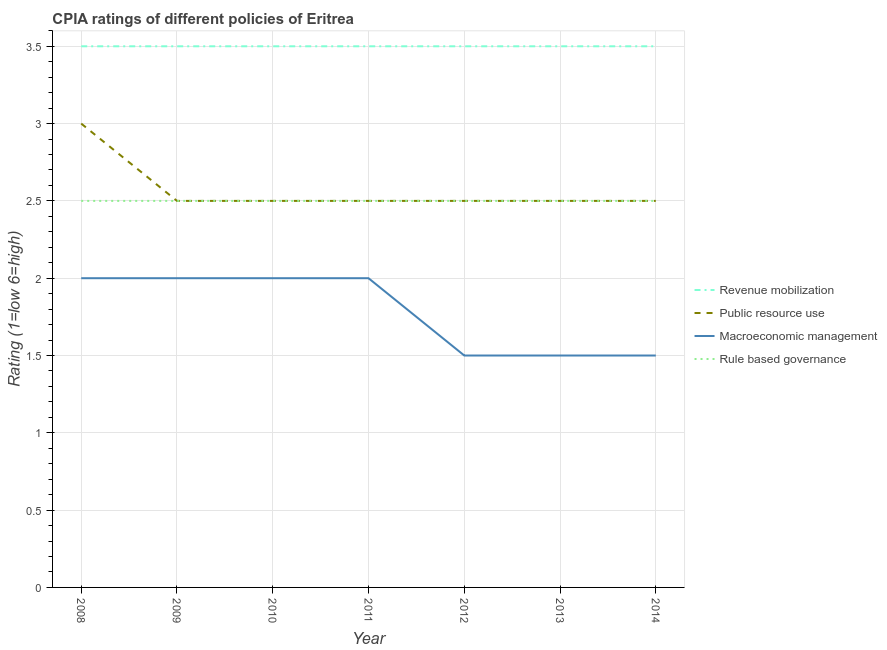How many different coloured lines are there?
Ensure brevity in your answer.  4. Does the line corresponding to cpia rating of revenue mobilization intersect with the line corresponding to cpia rating of macroeconomic management?
Offer a very short reply. No. Is the number of lines equal to the number of legend labels?
Make the answer very short. Yes. Across all years, what is the maximum cpia rating of revenue mobilization?
Offer a terse response. 3.5. In which year was the cpia rating of rule based governance maximum?
Provide a short and direct response. 2008. What is the difference between the cpia rating of rule based governance in 2008 and that in 2014?
Provide a succinct answer. 0. What is the average cpia rating of revenue mobilization per year?
Offer a very short reply. 3.5. What is the ratio of the cpia rating of rule based governance in 2009 to that in 2014?
Provide a succinct answer. 1. Is the difference between the cpia rating of rule based governance in 2009 and 2010 greater than the difference between the cpia rating of macroeconomic management in 2009 and 2010?
Ensure brevity in your answer.  No. What is the difference between the highest and the lowest cpia rating of revenue mobilization?
Provide a short and direct response. 0. In how many years, is the cpia rating of public resource use greater than the average cpia rating of public resource use taken over all years?
Make the answer very short. 1. Is the cpia rating of revenue mobilization strictly less than the cpia rating of macroeconomic management over the years?
Offer a terse response. No. What is the difference between two consecutive major ticks on the Y-axis?
Your response must be concise. 0.5. Does the graph contain grids?
Ensure brevity in your answer.  Yes. Where does the legend appear in the graph?
Offer a very short reply. Center right. How many legend labels are there?
Your answer should be compact. 4. How are the legend labels stacked?
Give a very brief answer. Vertical. What is the title of the graph?
Your answer should be compact. CPIA ratings of different policies of Eritrea. Does "Belgium" appear as one of the legend labels in the graph?
Ensure brevity in your answer.  No. What is the label or title of the Y-axis?
Offer a very short reply. Rating (1=low 6=high). What is the Rating (1=low 6=high) of Rule based governance in 2008?
Your response must be concise. 2.5. What is the Rating (1=low 6=high) of Public resource use in 2009?
Give a very brief answer. 2.5. What is the Rating (1=low 6=high) in Macroeconomic management in 2009?
Offer a very short reply. 2. What is the Rating (1=low 6=high) in Public resource use in 2010?
Ensure brevity in your answer.  2.5. What is the Rating (1=low 6=high) of Macroeconomic management in 2011?
Your response must be concise. 2. What is the Rating (1=low 6=high) of Rule based governance in 2012?
Keep it short and to the point. 2.5. What is the Rating (1=low 6=high) in Rule based governance in 2013?
Ensure brevity in your answer.  2.5. What is the Rating (1=low 6=high) in Revenue mobilization in 2014?
Offer a terse response. 3.5. What is the Rating (1=low 6=high) in Public resource use in 2014?
Offer a terse response. 2.5. What is the Rating (1=low 6=high) of Rule based governance in 2014?
Your response must be concise. 2.5. Across all years, what is the maximum Rating (1=low 6=high) of Revenue mobilization?
Provide a succinct answer. 3.5. Across all years, what is the minimum Rating (1=low 6=high) of Macroeconomic management?
Your answer should be compact. 1.5. What is the total Rating (1=low 6=high) in Revenue mobilization in the graph?
Ensure brevity in your answer.  24.5. What is the total Rating (1=low 6=high) of Public resource use in the graph?
Your response must be concise. 18. What is the total Rating (1=low 6=high) of Rule based governance in the graph?
Your answer should be compact. 17.5. What is the difference between the Rating (1=low 6=high) of Public resource use in 2008 and that in 2009?
Provide a succinct answer. 0.5. What is the difference between the Rating (1=low 6=high) of Rule based governance in 2008 and that in 2009?
Offer a very short reply. 0. What is the difference between the Rating (1=low 6=high) of Public resource use in 2008 and that in 2010?
Your answer should be compact. 0.5. What is the difference between the Rating (1=low 6=high) of Rule based governance in 2008 and that in 2011?
Offer a terse response. 0. What is the difference between the Rating (1=low 6=high) of Revenue mobilization in 2008 and that in 2012?
Your response must be concise. 0. What is the difference between the Rating (1=low 6=high) of Revenue mobilization in 2008 and that in 2013?
Give a very brief answer. 0. What is the difference between the Rating (1=low 6=high) of Public resource use in 2008 and that in 2013?
Offer a terse response. 0.5. What is the difference between the Rating (1=low 6=high) in Macroeconomic management in 2008 and that in 2013?
Your answer should be very brief. 0.5. What is the difference between the Rating (1=low 6=high) in Public resource use in 2008 and that in 2014?
Your answer should be very brief. 0.5. What is the difference between the Rating (1=low 6=high) in Rule based governance in 2008 and that in 2014?
Offer a very short reply. 0. What is the difference between the Rating (1=low 6=high) in Macroeconomic management in 2009 and that in 2010?
Ensure brevity in your answer.  0. What is the difference between the Rating (1=low 6=high) of Macroeconomic management in 2009 and that in 2011?
Provide a succinct answer. 0. What is the difference between the Rating (1=low 6=high) of Public resource use in 2009 and that in 2012?
Offer a very short reply. 0. What is the difference between the Rating (1=low 6=high) of Macroeconomic management in 2009 and that in 2012?
Keep it short and to the point. 0.5. What is the difference between the Rating (1=low 6=high) in Rule based governance in 2009 and that in 2012?
Your answer should be very brief. 0. What is the difference between the Rating (1=low 6=high) in Revenue mobilization in 2009 and that in 2014?
Make the answer very short. 0. What is the difference between the Rating (1=low 6=high) in Public resource use in 2009 and that in 2014?
Give a very brief answer. 0. What is the difference between the Rating (1=low 6=high) of Macroeconomic management in 2009 and that in 2014?
Offer a terse response. 0.5. What is the difference between the Rating (1=low 6=high) of Public resource use in 2010 and that in 2011?
Ensure brevity in your answer.  0. What is the difference between the Rating (1=low 6=high) of Revenue mobilization in 2010 and that in 2013?
Give a very brief answer. 0. What is the difference between the Rating (1=low 6=high) in Public resource use in 2010 and that in 2013?
Ensure brevity in your answer.  0. What is the difference between the Rating (1=low 6=high) of Macroeconomic management in 2010 and that in 2013?
Ensure brevity in your answer.  0.5. What is the difference between the Rating (1=low 6=high) of Rule based governance in 2010 and that in 2013?
Provide a short and direct response. 0. What is the difference between the Rating (1=low 6=high) of Revenue mobilization in 2010 and that in 2014?
Your answer should be very brief. 0. What is the difference between the Rating (1=low 6=high) of Public resource use in 2010 and that in 2014?
Your answer should be very brief. 0. What is the difference between the Rating (1=low 6=high) in Macroeconomic management in 2010 and that in 2014?
Keep it short and to the point. 0.5. What is the difference between the Rating (1=low 6=high) of Rule based governance in 2010 and that in 2014?
Ensure brevity in your answer.  0. What is the difference between the Rating (1=low 6=high) in Public resource use in 2011 and that in 2012?
Give a very brief answer. 0. What is the difference between the Rating (1=low 6=high) of Rule based governance in 2011 and that in 2012?
Offer a very short reply. 0. What is the difference between the Rating (1=low 6=high) in Revenue mobilization in 2011 and that in 2013?
Provide a succinct answer. 0. What is the difference between the Rating (1=low 6=high) in Macroeconomic management in 2011 and that in 2013?
Keep it short and to the point. 0.5. What is the difference between the Rating (1=low 6=high) in Macroeconomic management in 2011 and that in 2014?
Offer a very short reply. 0.5. What is the difference between the Rating (1=low 6=high) of Revenue mobilization in 2012 and that in 2013?
Make the answer very short. 0. What is the difference between the Rating (1=low 6=high) of Macroeconomic management in 2012 and that in 2013?
Ensure brevity in your answer.  0. What is the difference between the Rating (1=low 6=high) of Rule based governance in 2012 and that in 2013?
Offer a terse response. 0. What is the difference between the Rating (1=low 6=high) of Public resource use in 2012 and that in 2014?
Provide a succinct answer. 0. What is the difference between the Rating (1=low 6=high) in Public resource use in 2013 and that in 2014?
Your answer should be compact. 0. What is the difference between the Rating (1=low 6=high) in Revenue mobilization in 2008 and the Rating (1=low 6=high) in Public resource use in 2009?
Provide a succinct answer. 1. What is the difference between the Rating (1=low 6=high) of Public resource use in 2008 and the Rating (1=low 6=high) of Macroeconomic management in 2009?
Your answer should be very brief. 1. What is the difference between the Rating (1=low 6=high) in Revenue mobilization in 2008 and the Rating (1=low 6=high) in Macroeconomic management in 2010?
Your response must be concise. 1.5. What is the difference between the Rating (1=low 6=high) of Revenue mobilization in 2008 and the Rating (1=low 6=high) of Rule based governance in 2010?
Offer a very short reply. 1. What is the difference between the Rating (1=low 6=high) of Public resource use in 2008 and the Rating (1=low 6=high) of Macroeconomic management in 2010?
Provide a succinct answer. 1. What is the difference between the Rating (1=low 6=high) of Revenue mobilization in 2008 and the Rating (1=low 6=high) of Public resource use in 2011?
Give a very brief answer. 1. What is the difference between the Rating (1=low 6=high) in Revenue mobilization in 2008 and the Rating (1=low 6=high) in Macroeconomic management in 2011?
Offer a very short reply. 1.5. What is the difference between the Rating (1=low 6=high) in Macroeconomic management in 2008 and the Rating (1=low 6=high) in Rule based governance in 2011?
Keep it short and to the point. -0.5. What is the difference between the Rating (1=low 6=high) of Public resource use in 2008 and the Rating (1=low 6=high) of Rule based governance in 2012?
Your response must be concise. 0.5. What is the difference between the Rating (1=low 6=high) in Revenue mobilization in 2008 and the Rating (1=low 6=high) in Public resource use in 2013?
Keep it short and to the point. 1. What is the difference between the Rating (1=low 6=high) of Revenue mobilization in 2008 and the Rating (1=low 6=high) of Macroeconomic management in 2013?
Keep it short and to the point. 2. What is the difference between the Rating (1=low 6=high) in Public resource use in 2008 and the Rating (1=low 6=high) in Macroeconomic management in 2013?
Give a very brief answer. 1.5. What is the difference between the Rating (1=low 6=high) in Revenue mobilization in 2008 and the Rating (1=low 6=high) in Public resource use in 2014?
Keep it short and to the point. 1. What is the difference between the Rating (1=low 6=high) in Revenue mobilization in 2008 and the Rating (1=low 6=high) in Macroeconomic management in 2014?
Keep it short and to the point. 2. What is the difference between the Rating (1=low 6=high) in Revenue mobilization in 2008 and the Rating (1=low 6=high) in Rule based governance in 2014?
Ensure brevity in your answer.  1. What is the difference between the Rating (1=low 6=high) of Revenue mobilization in 2009 and the Rating (1=low 6=high) of Public resource use in 2010?
Offer a terse response. 1. What is the difference between the Rating (1=low 6=high) in Revenue mobilization in 2009 and the Rating (1=low 6=high) in Macroeconomic management in 2010?
Provide a short and direct response. 1.5. What is the difference between the Rating (1=low 6=high) in Public resource use in 2009 and the Rating (1=low 6=high) in Rule based governance in 2010?
Offer a very short reply. 0. What is the difference between the Rating (1=low 6=high) of Revenue mobilization in 2009 and the Rating (1=low 6=high) of Macroeconomic management in 2011?
Ensure brevity in your answer.  1.5. What is the difference between the Rating (1=low 6=high) of Revenue mobilization in 2009 and the Rating (1=low 6=high) of Rule based governance in 2011?
Give a very brief answer. 1. What is the difference between the Rating (1=low 6=high) in Macroeconomic management in 2009 and the Rating (1=low 6=high) in Rule based governance in 2011?
Offer a very short reply. -0.5. What is the difference between the Rating (1=low 6=high) in Revenue mobilization in 2009 and the Rating (1=low 6=high) in Macroeconomic management in 2012?
Ensure brevity in your answer.  2. What is the difference between the Rating (1=low 6=high) of Public resource use in 2009 and the Rating (1=low 6=high) of Macroeconomic management in 2012?
Offer a very short reply. 1. What is the difference between the Rating (1=low 6=high) in Macroeconomic management in 2009 and the Rating (1=low 6=high) in Rule based governance in 2012?
Make the answer very short. -0.5. What is the difference between the Rating (1=low 6=high) in Revenue mobilization in 2009 and the Rating (1=low 6=high) in Public resource use in 2013?
Keep it short and to the point. 1. What is the difference between the Rating (1=low 6=high) of Revenue mobilization in 2009 and the Rating (1=low 6=high) of Rule based governance in 2013?
Give a very brief answer. 1. What is the difference between the Rating (1=low 6=high) in Public resource use in 2009 and the Rating (1=low 6=high) in Macroeconomic management in 2013?
Offer a terse response. 1. What is the difference between the Rating (1=low 6=high) of Revenue mobilization in 2009 and the Rating (1=low 6=high) of Macroeconomic management in 2014?
Your answer should be very brief. 2. What is the difference between the Rating (1=low 6=high) of Macroeconomic management in 2009 and the Rating (1=low 6=high) of Rule based governance in 2014?
Your answer should be compact. -0.5. What is the difference between the Rating (1=low 6=high) in Revenue mobilization in 2010 and the Rating (1=low 6=high) in Rule based governance in 2011?
Your response must be concise. 1. What is the difference between the Rating (1=low 6=high) of Macroeconomic management in 2010 and the Rating (1=low 6=high) of Rule based governance in 2011?
Give a very brief answer. -0.5. What is the difference between the Rating (1=low 6=high) of Revenue mobilization in 2010 and the Rating (1=low 6=high) of Macroeconomic management in 2013?
Provide a succinct answer. 2. What is the difference between the Rating (1=low 6=high) in Public resource use in 2010 and the Rating (1=low 6=high) in Macroeconomic management in 2013?
Offer a very short reply. 1. What is the difference between the Rating (1=low 6=high) in Macroeconomic management in 2010 and the Rating (1=low 6=high) in Rule based governance in 2013?
Provide a succinct answer. -0.5. What is the difference between the Rating (1=low 6=high) in Revenue mobilization in 2010 and the Rating (1=low 6=high) in Public resource use in 2014?
Your answer should be compact. 1. What is the difference between the Rating (1=low 6=high) in Public resource use in 2010 and the Rating (1=low 6=high) in Macroeconomic management in 2014?
Give a very brief answer. 1. What is the difference between the Rating (1=low 6=high) of Macroeconomic management in 2011 and the Rating (1=low 6=high) of Rule based governance in 2012?
Keep it short and to the point. -0.5. What is the difference between the Rating (1=low 6=high) in Revenue mobilization in 2011 and the Rating (1=low 6=high) in Macroeconomic management in 2013?
Offer a terse response. 2. What is the difference between the Rating (1=low 6=high) in Public resource use in 2011 and the Rating (1=low 6=high) in Rule based governance in 2013?
Offer a very short reply. 0. What is the difference between the Rating (1=low 6=high) in Revenue mobilization in 2011 and the Rating (1=low 6=high) in Public resource use in 2014?
Your response must be concise. 1. What is the difference between the Rating (1=low 6=high) of Revenue mobilization in 2011 and the Rating (1=low 6=high) of Rule based governance in 2014?
Your answer should be very brief. 1. What is the difference between the Rating (1=low 6=high) in Public resource use in 2011 and the Rating (1=low 6=high) in Macroeconomic management in 2014?
Offer a very short reply. 1. What is the difference between the Rating (1=low 6=high) of Public resource use in 2011 and the Rating (1=low 6=high) of Rule based governance in 2014?
Provide a succinct answer. 0. What is the difference between the Rating (1=low 6=high) of Revenue mobilization in 2012 and the Rating (1=low 6=high) of Public resource use in 2013?
Your answer should be compact. 1. What is the difference between the Rating (1=low 6=high) of Revenue mobilization in 2012 and the Rating (1=low 6=high) of Macroeconomic management in 2013?
Your answer should be compact. 2. What is the difference between the Rating (1=low 6=high) in Revenue mobilization in 2012 and the Rating (1=low 6=high) in Rule based governance in 2013?
Make the answer very short. 1. What is the difference between the Rating (1=low 6=high) of Macroeconomic management in 2012 and the Rating (1=low 6=high) of Rule based governance in 2013?
Your response must be concise. -1. What is the difference between the Rating (1=low 6=high) in Revenue mobilization in 2012 and the Rating (1=low 6=high) in Macroeconomic management in 2014?
Your response must be concise. 2. What is the difference between the Rating (1=low 6=high) of Revenue mobilization in 2012 and the Rating (1=low 6=high) of Rule based governance in 2014?
Make the answer very short. 1. What is the difference between the Rating (1=low 6=high) of Public resource use in 2012 and the Rating (1=low 6=high) of Macroeconomic management in 2014?
Give a very brief answer. 1. What is the difference between the Rating (1=low 6=high) of Revenue mobilization in 2013 and the Rating (1=low 6=high) of Macroeconomic management in 2014?
Provide a succinct answer. 2. What is the difference between the Rating (1=low 6=high) of Public resource use in 2013 and the Rating (1=low 6=high) of Macroeconomic management in 2014?
Provide a short and direct response. 1. What is the difference between the Rating (1=low 6=high) of Public resource use in 2013 and the Rating (1=low 6=high) of Rule based governance in 2014?
Ensure brevity in your answer.  0. What is the difference between the Rating (1=low 6=high) in Macroeconomic management in 2013 and the Rating (1=low 6=high) in Rule based governance in 2014?
Make the answer very short. -1. What is the average Rating (1=low 6=high) of Revenue mobilization per year?
Offer a very short reply. 3.5. What is the average Rating (1=low 6=high) of Public resource use per year?
Your answer should be compact. 2.57. What is the average Rating (1=low 6=high) of Macroeconomic management per year?
Your answer should be compact. 1.79. In the year 2008, what is the difference between the Rating (1=low 6=high) of Revenue mobilization and Rating (1=low 6=high) of Rule based governance?
Your response must be concise. 1. In the year 2008, what is the difference between the Rating (1=low 6=high) of Macroeconomic management and Rating (1=low 6=high) of Rule based governance?
Ensure brevity in your answer.  -0.5. In the year 2009, what is the difference between the Rating (1=low 6=high) in Revenue mobilization and Rating (1=low 6=high) in Public resource use?
Your response must be concise. 1. In the year 2009, what is the difference between the Rating (1=low 6=high) in Revenue mobilization and Rating (1=low 6=high) in Rule based governance?
Provide a succinct answer. 1. In the year 2009, what is the difference between the Rating (1=low 6=high) in Public resource use and Rating (1=low 6=high) in Macroeconomic management?
Offer a very short reply. 0.5. In the year 2009, what is the difference between the Rating (1=low 6=high) in Public resource use and Rating (1=low 6=high) in Rule based governance?
Your answer should be compact. 0. In the year 2010, what is the difference between the Rating (1=low 6=high) of Revenue mobilization and Rating (1=low 6=high) of Public resource use?
Offer a terse response. 1. In the year 2010, what is the difference between the Rating (1=low 6=high) in Revenue mobilization and Rating (1=low 6=high) in Macroeconomic management?
Offer a terse response. 1.5. In the year 2010, what is the difference between the Rating (1=low 6=high) of Revenue mobilization and Rating (1=low 6=high) of Rule based governance?
Give a very brief answer. 1. In the year 2010, what is the difference between the Rating (1=low 6=high) of Public resource use and Rating (1=low 6=high) of Rule based governance?
Offer a very short reply. 0. In the year 2010, what is the difference between the Rating (1=low 6=high) of Macroeconomic management and Rating (1=low 6=high) of Rule based governance?
Offer a very short reply. -0.5. In the year 2011, what is the difference between the Rating (1=low 6=high) of Revenue mobilization and Rating (1=low 6=high) of Macroeconomic management?
Make the answer very short. 1.5. In the year 2011, what is the difference between the Rating (1=low 6=high) in Revenue mobilization and Rating (1=low 6=high) in Rule based governance?
Your answer should be compact. 1. In the year 2011, what is the difference between the Rating (1=low 6=high) of Macroeconomic management and Rating (1=low 6=high) of Rule based governance?
Make the answer very short. -0.5. In the year 2012, what is the difference between the Rating (1=low 6=high) in Revenue mobilization and Rating (1=low 6=high) in Macroeconomic management?
Provide a short and direct response. 2. In the year 2012, what is the difference between the Rating (1=low 6=high) in Revenue mobilization and Rating (1=low 6=high) in Rule based governance?
Ensure brevity in your answer.  1. In the year 2012, what is the difference between the Rating (1=low 6=high) of Public resource use and Rating (1=low 6=high) of Macroeconomic management?
Ensure brevity in your answer.  1. In the year 2012, what is the difference between the Rating (1=low 6=high) in Macroeconomic management and Rating (1=low 6=high) in Rule based governance?
Your answer should be very brief. -1. In the year 2013, what is the difference between the Rating (1=low 6=high) of Revenue mobilization and Rating (1=low 6=high) of Macroeconomic management?
Give a very brief answer. 2. In the year 2013, what is the difference between the Rating (1=low 6=high) in Public resource use and Rating (1=low 6=high) in Rule based governance?
Your answer should be compact. 0. In the year 2013, what is the difference between the Rating (1=low 6=high) of Macroeconomic management and Rating (1=low 6=high) of Rule based governance?
Make the answer very short. -1. In the year 2014, what is the difference between the Rating (1=low 6=high) in Revenue mobilization and Rating (1=low 6=high) in Rule based governance?
Offer a terse response. 1. In the year 2014, what is the difference between the Rating (1=low 6=high) in Macroeconomic management and Rating (1=low 6=high) in Rule based governance?
Your response must be concise. -1. What is the ratio of the Rating (1=low 6=high) of Revenue mobilization in 2008 to that in 2009?
Provide a succinct answer. 1. What is the ratio of the Rating (1=low 6=high) of Macroeconomic management in 2008 to that in 2009?
Provide a succinct answer. 1. What is the ratio of the Rating (1=low 6=high) of Rule based governance in 2008 to that in 2010?
Offer a terse response. 1. What is the ratio of the Rating (1=low 6=high) in Public resource use in 2008 to that in 2011?
Give a very brief answer. 1.2. What is the ratio of the Rating (1=low 6=high) of Macroeconomic management in 2008 to that in 2011?
Your answer should be very brief. 1. What is the ratio of the Rating (1=low 6=high) of Rule based governance in 2008 to that in 2011?
Your response must be concise. 1. What is the ratio of the Rating (1=low 6=high) of Revenue mobilization in 2008 to that in 2013?
Give a very brief answer. 1. What is the ratio of the Rating (1=low 6=high) of Public resource use in 2008 to that in 2013?
Offer a very short reply. 1.2. What is the ratio of the Rating (1=low 6=high) in Macroeconomic management in 2008 to that in 2013?
Offer a terse response. 1.33. What is the ratio of the Rating (1=low 6=high) of Rule based governance in 2008 to that in 2013?
Your answer should be very brief. 1. What is the ratio of the Rating (1=low 6=high) of Public resource use in 2008 to that in 2014?
Ensure brevity in your answer.  1.2. What is the ratio of the Rating (1=low 6=high) in Public resource use in 2009 to that in 2010?
Ensure brevity in your answer.  1. What is the ratio of the Rating (1=low 6=high) in Revenue mobilization in 2009 to that in 2011?
Offer a terse response. 1. What is the ratio of the Rating (1=low 6=high) in Macroeconomic management in 2009 to that in 2012?
Give a very brief answer. 1.33. What is the ratio of the Rating (1=low 6=high) of Public resource use in 2009 to that in 2013?
Give a very brief answer. 1. What is the ratio of the Rating (1=low 6=high) in Macroeconomic management in 2009 to that in 2013?
Your answer should be very brief. 1.33. What is the ratio of the Rating (1=low 6=high) of Rule based governance in 2009 to that in 2013?
Keep it short and to the point. 1. What is the ratio of the Rating (1=low 6=high) in Revenue mobilization in 2009 to that in 2014?
Ensure brevity in your answer.  1. What is the ratio of the Rating (1=low 6=high) in Public resource use in 2009 to that in 2014?
Your response must be concise. 1. What is the ratio of the Rating (1=low 6=high) in Macroeconomic management in 2010 to that in 2011?
Ensure brevity in your answer.  1. What is the ratio of the Rating (1=low 6=high) of Revenue mobilization in 2010 to that in 2012?
Keep it short and to the point. 1. What is the ratio of the Rating (1=low 6=high) of Revenue mobilization in 2010 to that in 2013?
Provide a short and direct response. 1. What is the ratio of the Rating (1=low 6=high) in Revenue mobilization in 2010 to that in 2014?
Ensure brevity in your answer.  1. What is the ratio of the Rating (1=low 6=high) in Macroeconomic management in 2010 to that in 2014?
Provide a succinct answer. 1.33. What is the ratio of the Rating (1=low 6=high) of Revenue mobilization in 2011 to that in 2012?
Keep it short and to the point. 1. What is the ratio of the Rating (1=low 6=high) in Public resource use in 2011 to that in 2012?
Give a very brief answer. 1. What is the ratio of the Rating (1=low 6=high) in Revenue mobilization in 2011 to that in 2013?
Your response must be concise. 1. What is the ratio of the Rating (1=low 6=high) of Macroeconomic management in 2011 to that in 2013?
Give a very brief answer. 1.33. What is the ratio of the Rating (1=low 6=high) in Rule based governance in 2011 to that in 2013?
Ensure brevity in your answer.  1. What is the ratio of the Rating (1=low 6=high) of Revenue mobilization in 2011 to that in 2014?
Your answer should be compact. 1. What is the ratio of the Rating (1=low 6=high) in Macroeconomic management in 2011 to that in 2014?
Make the answer very short. 1.33. What is the ratio of the Rating (1=low 6=high) of Revenue mobilization in 2012 to that in 2013?
Your answer should be compact. 1. What is the ratio of the Rating (1=low 6=high) of Public resource use in 2012 to that in 2013?
Your response must be concise. 1. What is the ratio of the Rating (1=low 6=high) of Revenue mobilization in 2012 to that in 2014?
Your response must be concise. 1. What is the ratio of the Rating (1=low 6=high) of Revenue mobilization in 2013 to that in 2014?
Your response must be concise. 1. What is the ratio of the Rating (1=low 6=high) of Macroeconomic management in 2013 to that in 2014?
Your answer should be very brief. 1. What is the difference between the highest and the second highest Rating (1=low 6=high) of Revenue mobilization?
Your answer should be very brief. 0. What is the difference between the highest and the second highest Rating (1=low 6=high) in Macroeconomic management?
Your response must be concise. 0. What is the difference between the highest and the lowest Rating (1=low 6=high) of Revenue mobilization?
Your response must be concise. 0. What is the difference between the highest and the lowest Rating (1=low 6=high) of Macroeconomic management?
Keep it short and to the point. 0.5. What is the difference between the highest and the lowest Rating (1=low 6=high) of Rule based governance?
Offer a terse response. 0. 